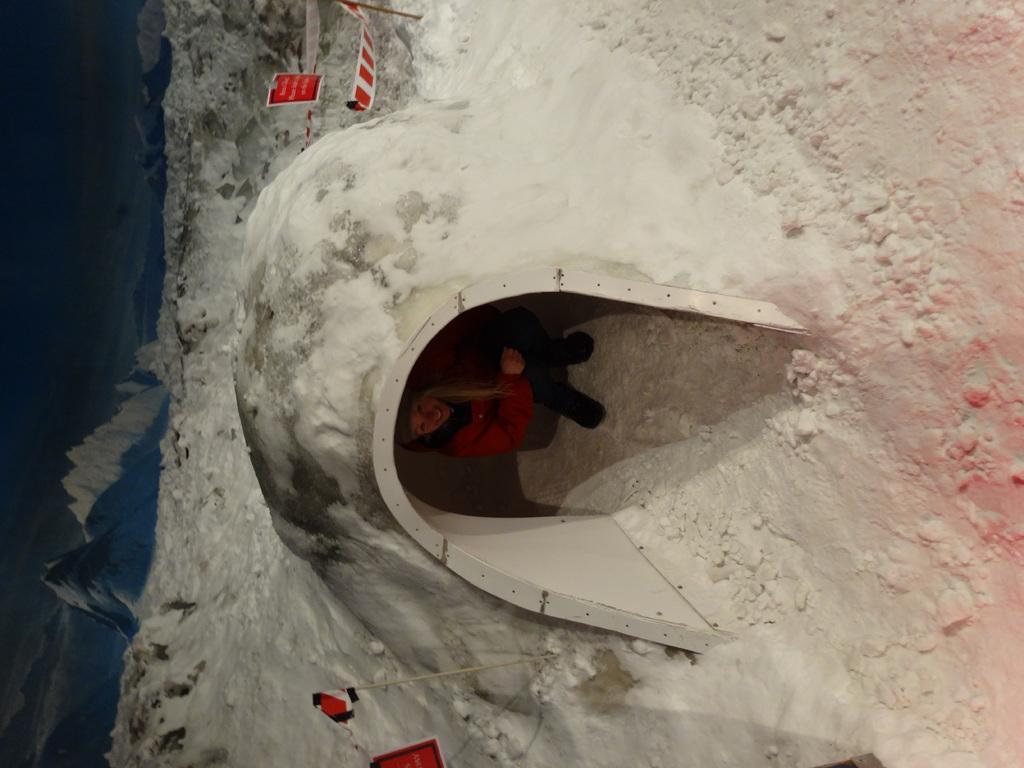Can you describe this image briefly? In this image, we can see a person is there inside the igloo. She is smiling and watching. At the top and bottom of the image, we can see banners and sticks. Left side of the image, we can see hills. 